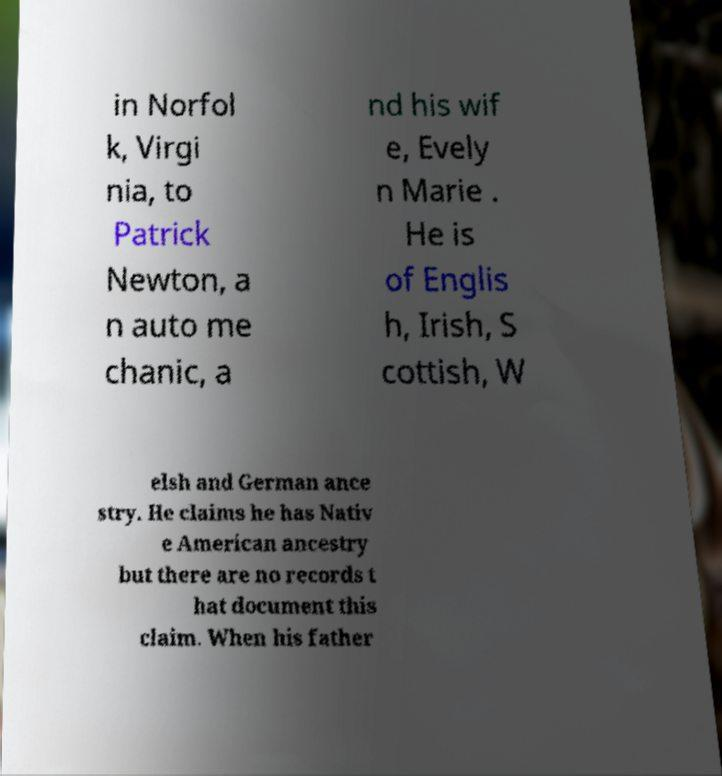For documentation purposes, I need the text within this image transcribed. Could you provide that? in Norfol k, Virgi nia, to Patrick Newton, a n auto me chanic, a nd his wif e, Evely n Marie . He is of Englis h, Irish, S cottish, W elsh and German ance stry. He claims he has Nativ e American ancestry but there are no records t hat document this claim. When his father 